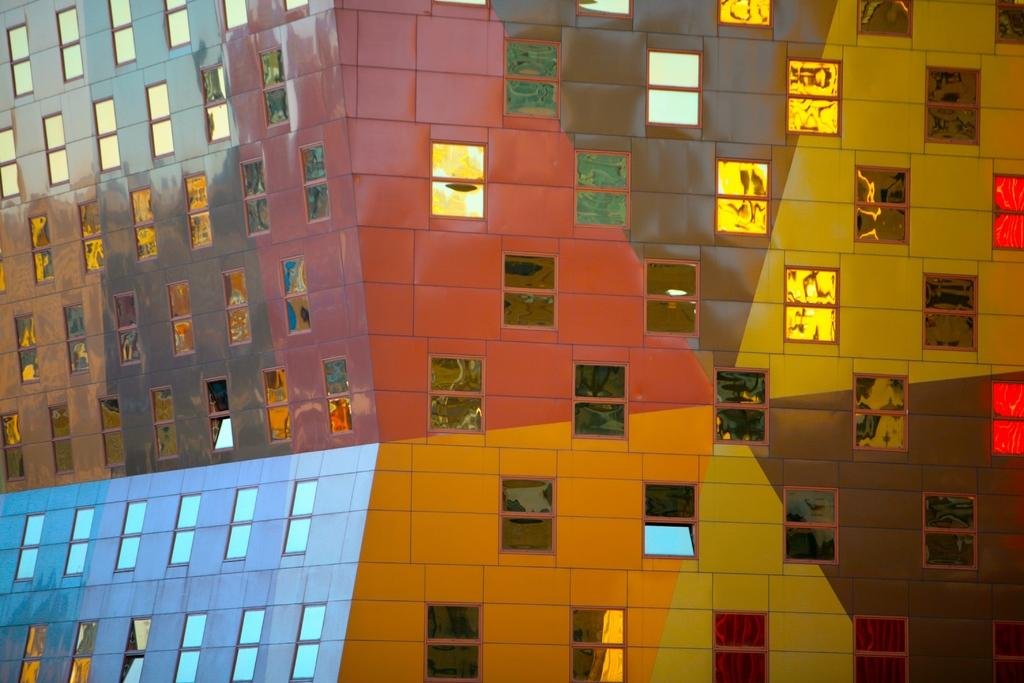What type of structure is visible in the image? There is a building in the image. What feature can be observed on the building? The building has glass windows. windows. How many glass lifts are present in the image? There is no mention of glass lifts in the provided facts, so we cannot determine their presence or quantity in the image. 